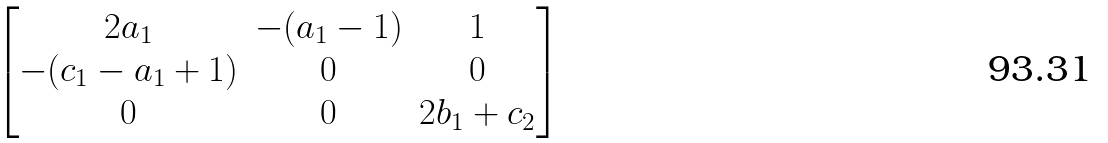<formula> <loc_0><loc_0><loc_500><loc_500>\begin{bmatrix} 2 a _ { 1 } & - ( a _ { 1 } - 1 ) & 1 \\ - ( c _ { 1 } - a _ { 1 } + 1 ) & 0 & 0 \\ 0 & 0 & 2 b _ { 1 } + c _ { 2 } \\ \end{bmatrix}</formula> 